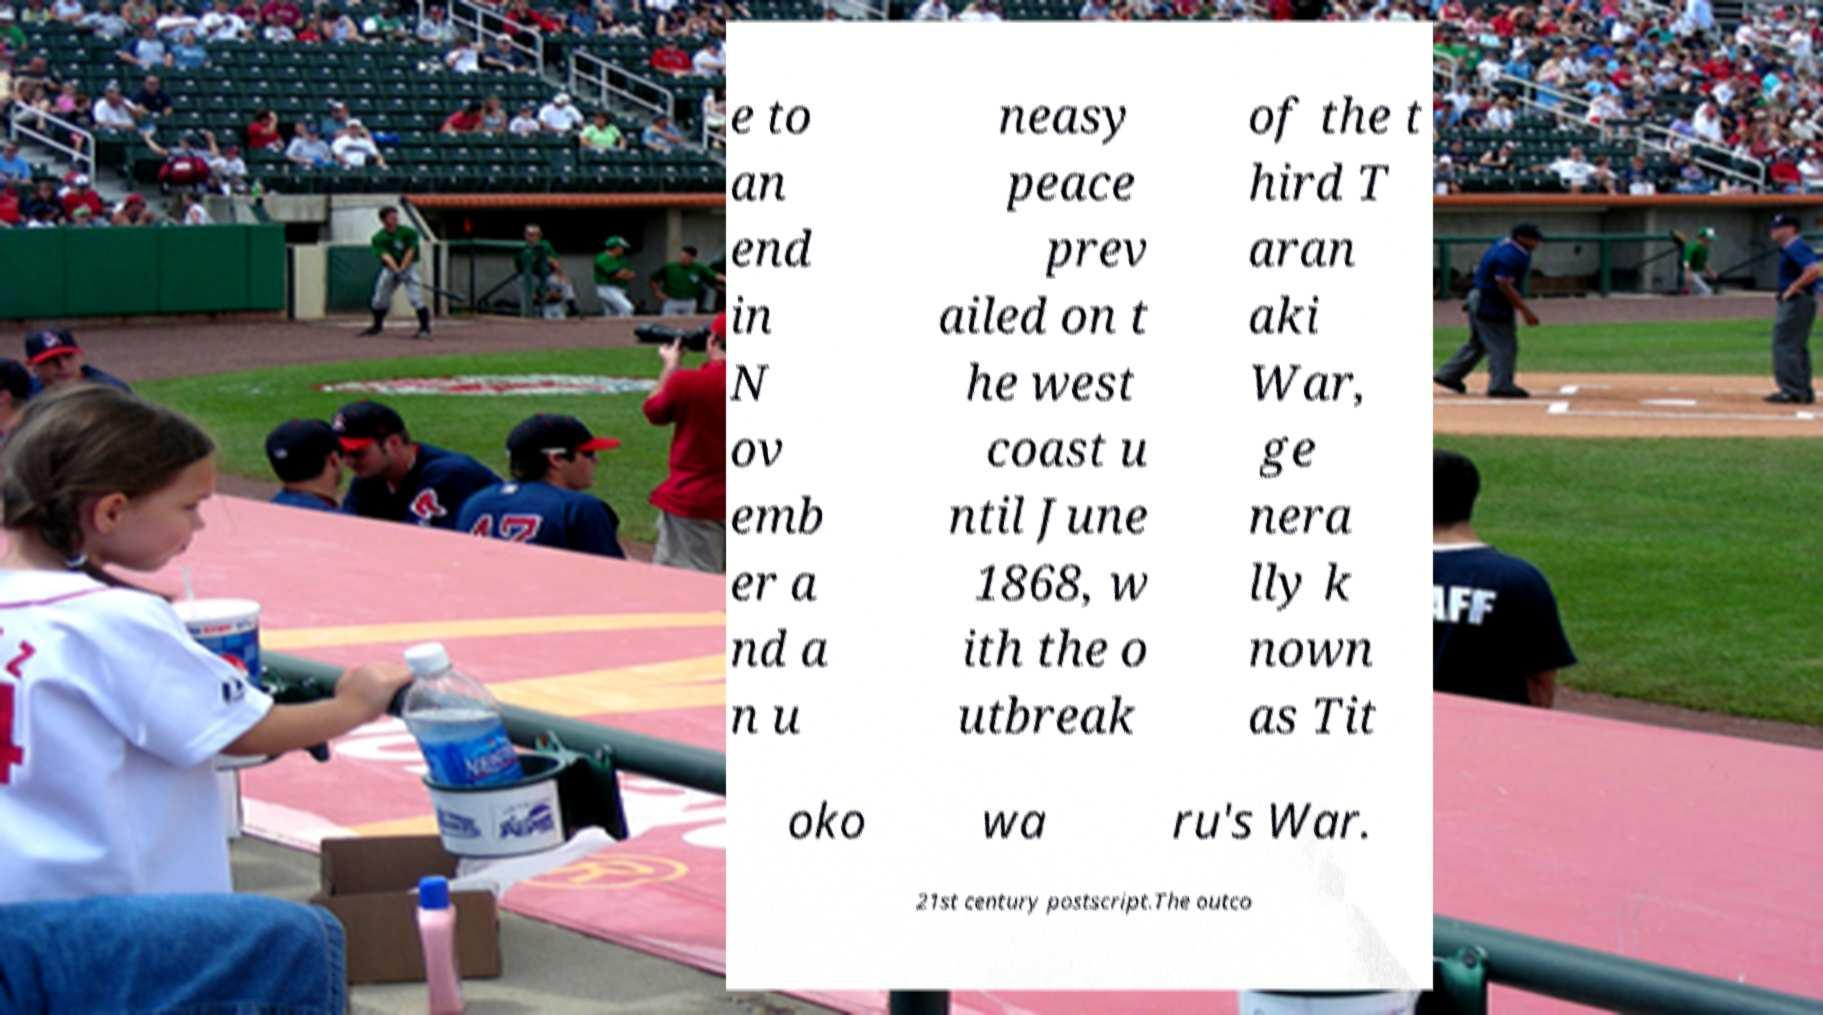There's text embedded in this image that I need extracted. Can you transcribe it verbatim? e to an end in N ov emb er a nd a n u neasy peace prev ailed on t he west coast u ntil June 1868, w ith the o utbreak of the t hird T aran aki War, ge nera lly k nown as Tit oko wa ru's War. 21st century postscript.The outco 